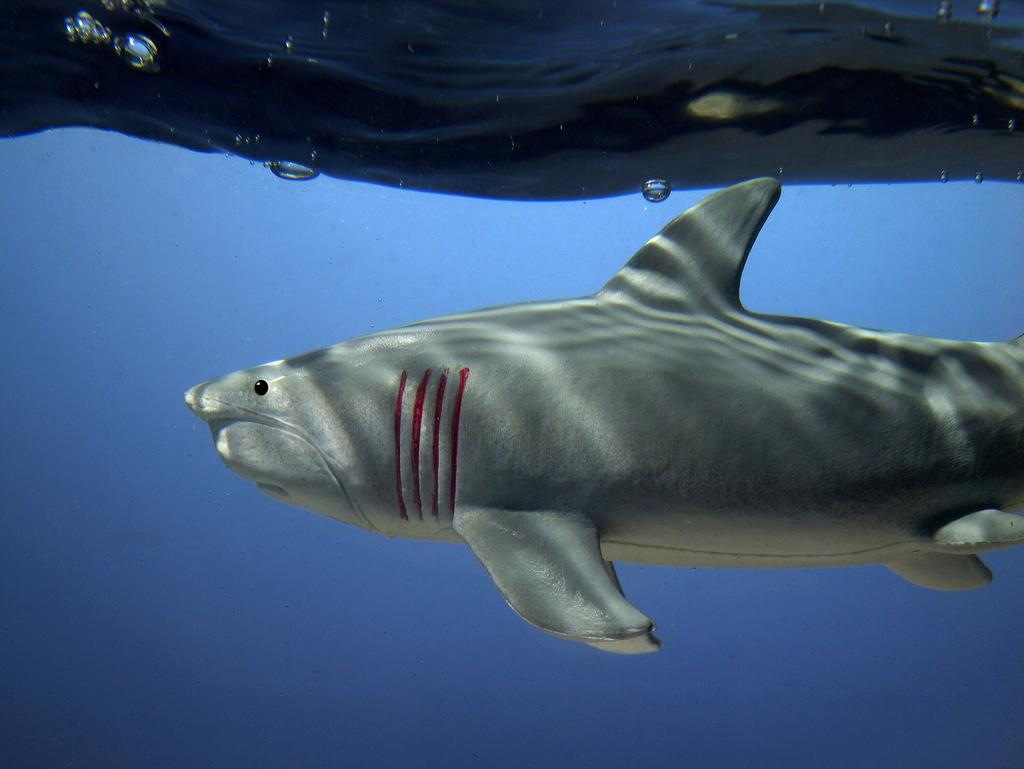What is the main subject in the center of the image? There is a fish in the center of the image. What is the surrounding environment of the image? There is water around the area of the image. What type of brush can be seen cleaning the vein in the image? There is no brush or vein present in the image; it features a fish in water. 